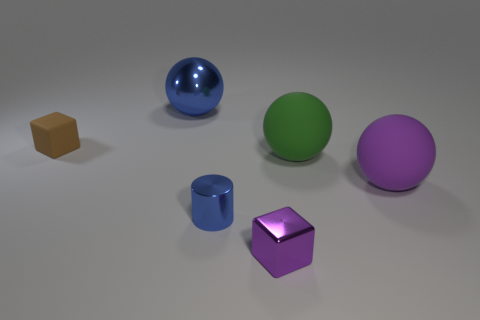Is there a small rubber block?
Give a very brief answer. Yes. What material is the tiny brown thing that is the same shape as the tiny purple thing?
Make the answer very short. Rubber. What is the size of the purple thing to the right of the cube right of the blue metallic object left of the tiny metal cylinder?
Give a very brief answer. Large. There is a big blue shiny object; are there any blue metallic spheres to the right of it?
Your answer should be very brief. No. There is a purple thing that is made of the same material as the small cylinder; what size is it?
Ensure brevity in your answer.  Small. What number of blue metallic objects have the same shape as the big green rubber object?
Your response must be concise. 1. Does the big blue ball have the same material as the cube that is behind the large purple sphere?
Ensure brevity in your answer.  No. Are there more small rubber blocks left of the cylinder than small brown rubber objects?
Offer a terse response. No. What is the shape of the tiny shiny object that is the same color as the shiny sphere?
Make the answer very short. Cylinder. Is there a cyan cylinder that has the same material as the tiny brown cube?
Your response must be concise. No. 